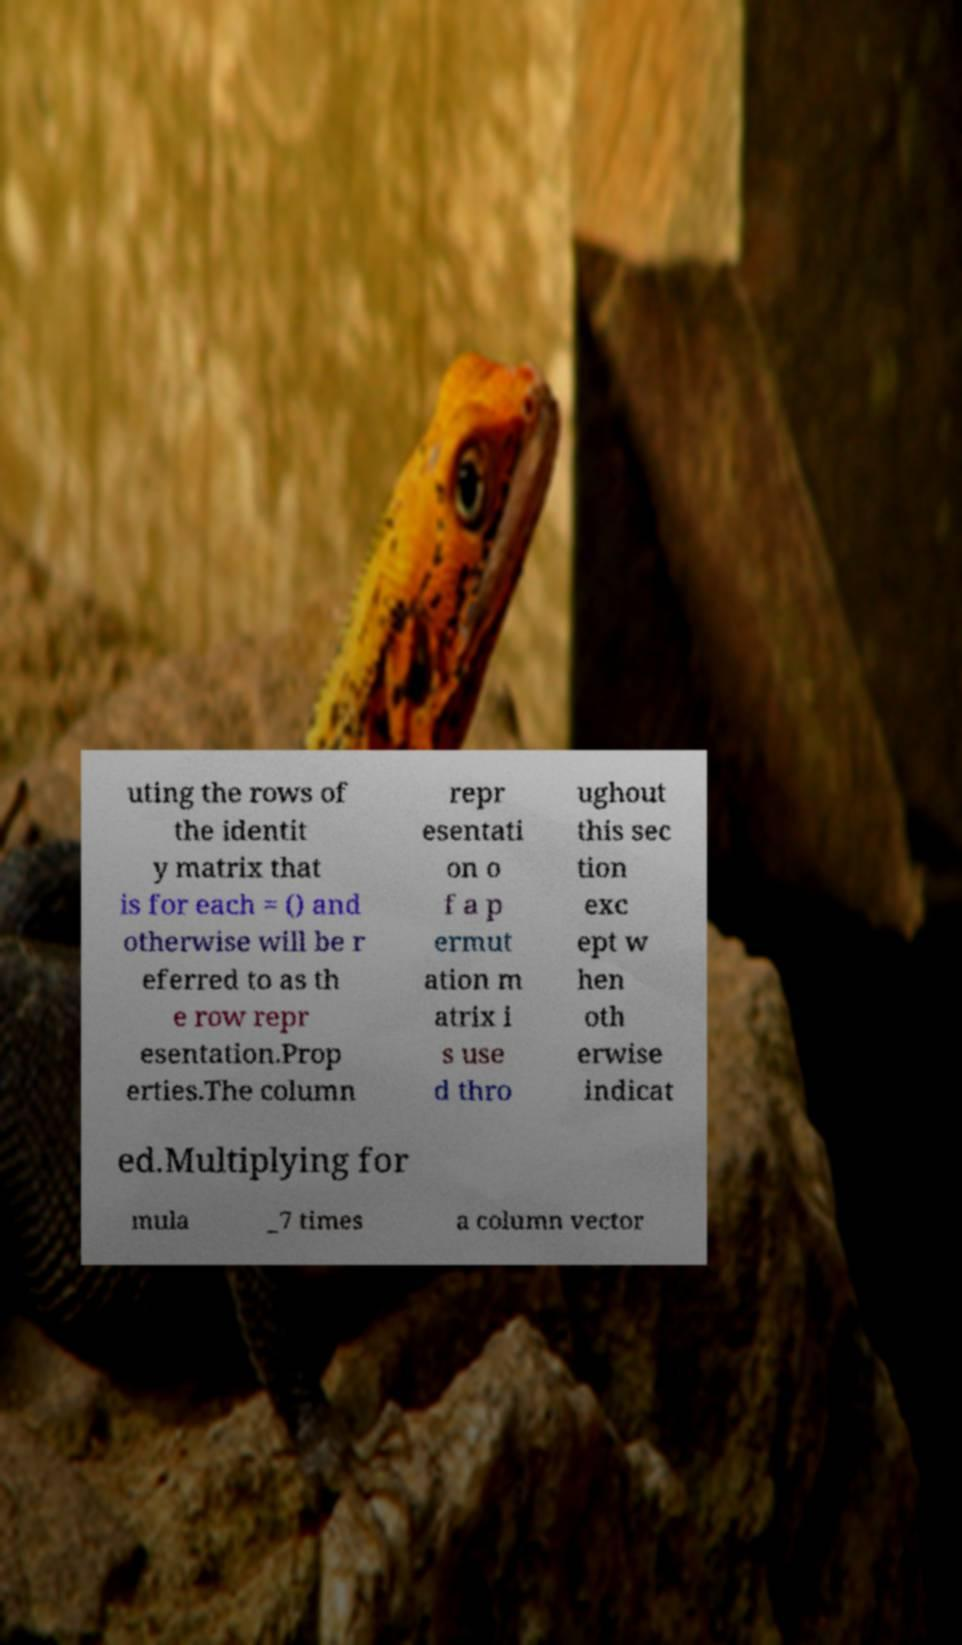Could you extract and type out the text from this image? uting the rows of the identit y matrix that is for each = () and otherwise will be r eferred to as th e row repr esentation.Prop erties.The column repr esentati on o f a p ermut ation m atrix i s use d thro ughout this sec tion exc ept w hen oth erwise indicat ed.Multiplying for mula _7 times a column vector 